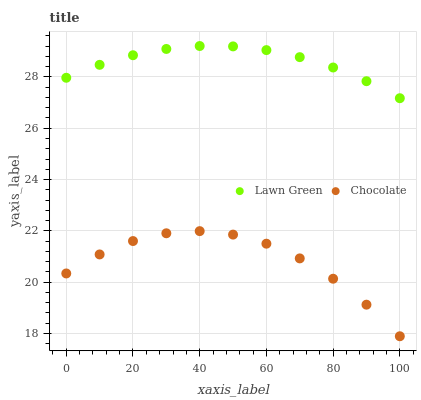Does Chocolate have the minimum area under the curve?
Answer yes or no. Yes. Does Lawn Green have the maximum area under the curve?
Answer yes or no. Yes. Does Chocolate have the maximum area under the curve?
Answer yes or no. No. Is Lawn Green the smoothest?
Answer yes or no. Yes. Is Chocolate the roughest?
Answer yes or no. Yes. Is Chocolate the smoothest?
Answer yes or no. No. Does Chocolate have the lowest value?
Answer yes or no. Yes. Does Lawn Green have the highest value?
Answer yes or no. Yes. Does Chocolate have the highest value?
Answer yes or no. No. Is Chocolate less than Lawn Green?
Answer yes or no. Yes. Is Lawn Green greater than Chocolate?
Answer yes or no. Yes. Does Chocolate intersect Lawn Green?
Answer yes or no. No. 